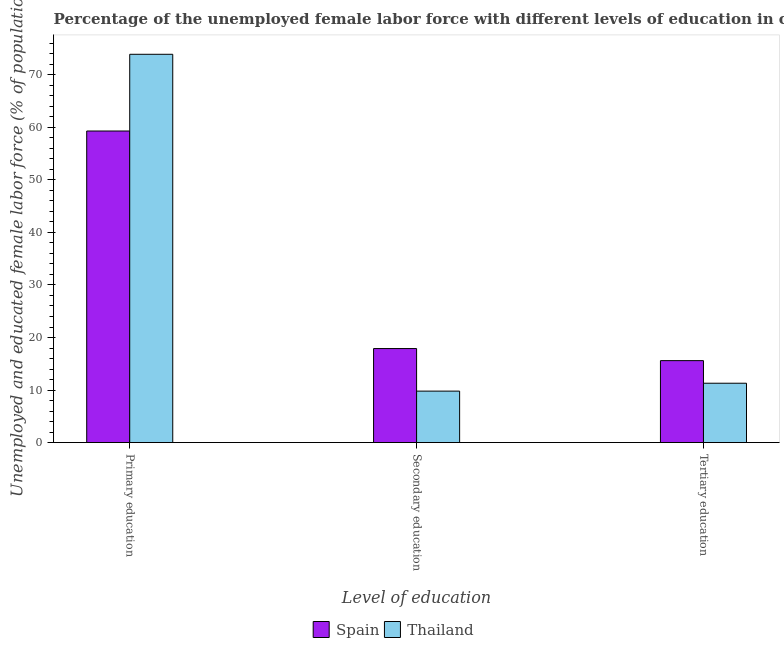Are the number of bars per tick equal to the number of legend labels?
Give a very brief answer. Yes. Are the number of bars on each tick of the X-axis equal?
Ensure brevity in your answer.  Yes. How many bars are there on the 3rd tick from the left?
Make the answer very short. 2. How many bars are there on the 2nd tick from the right?
Provide a short and direct response. 2. What is the label of the 2nd group of bars from the left?
Your response must be concise. Secondary education. What is the percentage of female labor force who received secondary education in Spain?
Give a very brief answer. 17.9. Across all countries, what is the maximum percentage of female labor force who received tertiary education?
Your response must be concise. 15.6. Across all countries, what is the minimum percentage of female labor force who received secondary education?
Offer a terse response. 9.8. In which country was the percentage of female labor force who received primary education maximum?
Provide a short and direct response. Thailand. In which country was the percentage of female labor force who received tertiary education minimum?
Your answer should be compact. Thailand. What is the total percentage of female labor force who received tertiary education in the graph?
Offer a terse response. 26.9. What is the difference between the percentage of female labor force who received tertiary education in Thailand and that in Spain?
Offer a terse response. -4.3. What is the difference between the percentage of female labor force who received primary education in Thailand and the percentage of female labor force who received secondary education in Spain?
Give a very brief answer. 56. What is the average percentage of female labor force who received primary education per country?
Your answer should be compact. 66.6. What is the difference between the percentage of female labor force who received tertiary education and percentage of female labor force who received secondary education in Thailand?
Keep it short and to the point. 1.5. In how many countries, is the percentage of female labor force who received tertiary education greater than 50 %?
Ensure brevity in your answer.  0. What is the ratio of the percentage of female labor force who received tertiary education in Thailand to that in Spain?
Give a very brief answer. 0.72. Is the difference between the percentage of female labor force who received secondary education in Thailand and Spain greater than the difference between the percentage of female labor force who received primary education in Thailand and Spain?
Ensure brevity in your answer.  No. What is the difference between the highest and the second highest percentage of female labor force who received primary education?
Provide a short and direct response. 14.6. What is the difference between the highest and the lowest percentage of female labor force who received secondary education?
Keep it short and to the point. 8.1. In how many countries, is the percentage of female labor force who received primary education greater than the average percentage of female labor force who received primary education taken over all countries?
Make the answer very short. 1. Is the sum of the percentage of female labor force who received primary education in Thailand and Spain greater than the maximum percentage of female labor force who received secondary education across all countries?
Provide a succinct answer. Yes. What does the 1st bar from the left in Secondary education represents?
Offer a very short reply. Spain. What does the 1st bar from the right in Secondary education represents?
Provide a succinct answer. Thailand. Are all the bars in the graph horizontal?
Make the answer very short. No. Are the values on the major ticks of Y-axis written in scientific E-notation?
Offer a very short reply. No. Does the graph contain any zero values?
Ensure brevity in your answer.  No. Does the graph contain grids?
Provide a succinct answer. No. Where does the legend appear in the graph?
Your answer should be very brief. Bottom center. How many legend labels are there?
Keep it short and to the point. 2. What is the title of the graph?
Offer a very short reply. Percentage of the unemployed female labor force with different levels of education in countries. What is the label or title of the X-axis?
Your response must be concise. Level of education. What is the label or title of the Y-axis?
Offer a terse response. Unemployed and educated female labor force (% of population). What is the Unemployed and educated female labor force (% of population) in Spain in Primary education?
Your answer should be compact. 59.3. What is the Unemployed and educated female labor force (% of population) in Thailand in Primary education?
Provide a short and direct response. 73.9. What is the Unemployed and educated female labor force (% of population) in Spain in Secondary education?
Give a very brief answer. 17.9. What is the Unemployed and educated female labor force (% of population) of Thailand in Secondary education?
Provide a short and direct response. 9.8. What is the Unemployed and educated female labor force (% of population) in Spain in Tertiary education?
Your answer should be compact. 15.6. What is the Unemployed and educated female labor force (% of population) in Thailand in Tertiary education?
Provide a succinct answer. 11.3. Across all Level of education, what is the maximum Unemployed and educated female labor force (% of population) of Spain?
Keep it short and to the point. 59.3. Across all Level of education, what is the maximum Unemployed and educated female labor force (% of population) of Thailand?
Your answer should be very brief. 73.9. Across all Level of education, what is the minimum Unemployed and educated female labor force (% of population) of Spain?
Ensure brevity in your answer.  15.6. Across all Level of education, what is the minimum Unemployed and educated female labor force (% of population) of Thailand?
Give a very brief answer. 9.8. What is the total Unemployed and educated female labor force (% of population) in Spain in the graph?
Provide a short and direct response. 92.8. What is the difference between the Unemployed and educated female labor force (% of population) of Spain in Primary education and that in Secondary education?
Your response must be concise. 41.4. What is the difference between the Unemployed and educated female labor force (% of population) of Thailand in Primary education and that in Secondary education?
Offer a terse response. 64.1. What is the difference between the Unemployed and educated female labor force (% of population) in Spain in Primary education and that in Tertiary education?
Offer a very short reply. 43.7. What is the difference between the Unemployed and educated female labor force (% of population) in Thailand in Primary education and that in Tertiary education?
Ensure brevity in your answer.  62.6. What is the difference between the Unemployed and educated female labor force (% of population) of Spain in Primary education and the Unemployed and educated female labor force (% of population) of Thailand in Secondary education?
Provide a succinct answer. 49.5. What is the difference between the Unemployed and educated female labor force (% of population) in Spain in Secondary education and the Unemployed and educated female labor force (% of population) in Thailand in Tertiary education?
Give a very brief answer. 6.6. What is the average Unemployed and educated female labor force (% of population) of Spain per Level of education?
Provide a succinct answer. 30.93. What is the average Unemployed and educated female labor force (% of population) in Thailand per Level of education?
Your answer should be very brief. 31.67. What is the difference between the Unemployed and educated female labor force (% of population) of Spain and Unemployed and educated female labor force (% of population) of Thailand in Primary education?
Make the answer very short. -14.6. What is the difference between the Unemployed and educated female labor force (% of population) in Spain and Unemployed and educated female labor force (% of population) in Thailand in Tertiary education?
Your answer should be compact. 4.3. What is the ratio of the Unemployed and educated female labor force (% of population) of Spain in Primary education to that in Secondary education?
Offer a terse response. 3.31. What is the ratio of the Unemployed and educated female labor force (% of population) of Thailand in Primary education to that in Secondary education?
Offer a terse response. 7.54. What is the ratio of the Unemployed and educated female labor force (% of population) in Spain in Primary education to that in Tertiary education?
Provide a succinct answer. 3.8. What is the ratio of the Unemployed and educated female labor force (% of population) of Thailand in Primary education to that in Tertiary education?
Provide a short and direct response. 6.54. What is the ratio of the Unemployed and educated female labor force (% of population) of Spain in Secondary education to that in Tertiary education?
Provide a succinct answer. 1.15. What is the ratio of the Unemployed and educated female labor force (% of population) of Thailand in Secondary education to that in Tertiary education?
Make the answer very short. 0.87. What is the difference between the highest and the second highest Unemployed and educated female labor force (% of population) of Spain?
Ensure brevity in your answer.  41.4. What is the difference between the highest and the second highest Unemployed and educated female labor force (% of population) of Thailand?
Offer a very short reply. 62.6. What is the difference between the highest and the lowest Unemployed and educated female labor force (% of population) of Spain?
Provide a succinct answer. 43.7. What is the difference between the highest and the lowest Unemployed and educated female labor force (% of population) of Thailand?
Give a very brief answer. 64.1. 